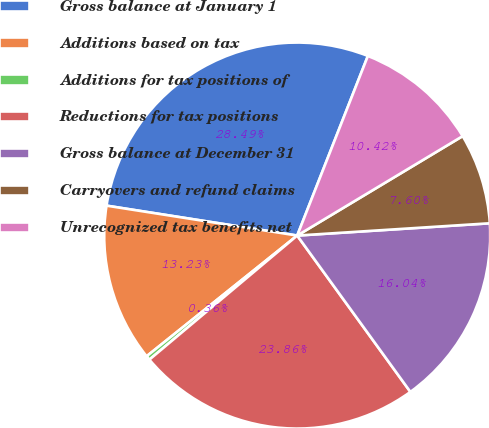Convert chart. <chart><loc_0><loc_0><loc_500><loc_500><pie_chart><fcel>Gross balance at January 1<fcel>Additions based on tax<fcel>Additions for tax positions of<fcel>Reductions for tax positions<fcel>Gross balance at December 31<fcel>Carryovers and refund claims<fcel>Unrecognized tax benefits net<nl><fcel>28.49%<fcel>13.23%<fcel>0.36%<fcel>23.86%<fcel>16.04%<fcel>7.6%<fcel>10.42%<nl></chart> 